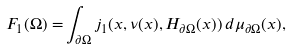<formula> <loc_0><loc_0><loc_500><loc_500>F _ { 1 } ( \Omega ) = & \int _ { \partial \Omega } j _ { 1 } ( x , \nu ( x ) , H _ { \partial \Omega } ( x ) ) \, d \mu _ { \partial \Omega } ( x ) ,</formula> 